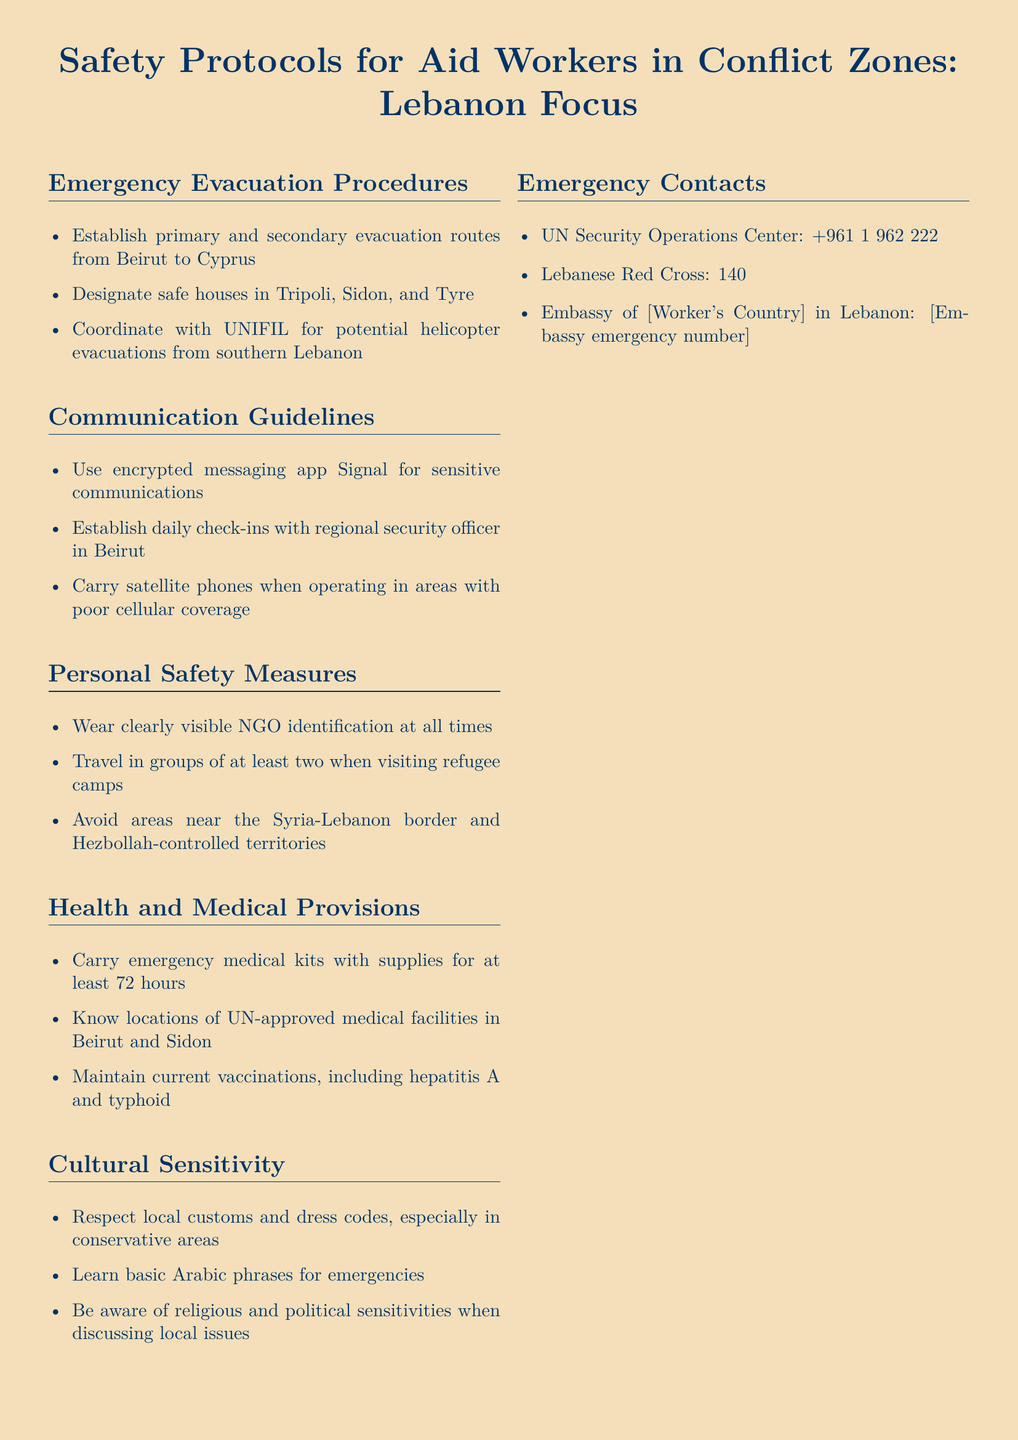what are the primary evacuation routes? The document states that the primary evacuation routes are from Beirut to Cyprus.
Answer: Beirut to Cyprus who should be contacted for emergency helicopter evacuations? The document mentions coordinating with UNIFIL for potential helicopter evacuations from southern Lebanon.
Answer: UNIFIL what communication app is recommended for sensitive communications? The document recommends using the encrypted messaging app Signal for sensitive communications.
Answer: Signal how many hours' worth of emergency medical supplies should be carried? The document indicates that emergency medical kits should be carried with supplies for at least 72 hours.
Answer: 72 hours what is the phone number for the UN Security Operations Center? The document provides the phone number: +961 1 962 222 for the UN Security Operations Center.
Answer: +961 1 962 222 why is it important to avoid areas near the Syria-Lebanon border? The document advises to avoid those areas due to potential security risks.
Answer: Security risks what is one personal safety measure mentioned in the document? The document states that traveling in groups of at least two is a personal safety measure.
Answer: Travel in groups of at least two what should workers maintain to ensure health provisions? The document emphasizes maintaining current vaccinations, including hepatitis A and typhoid.
Answer: Current vaccinations 